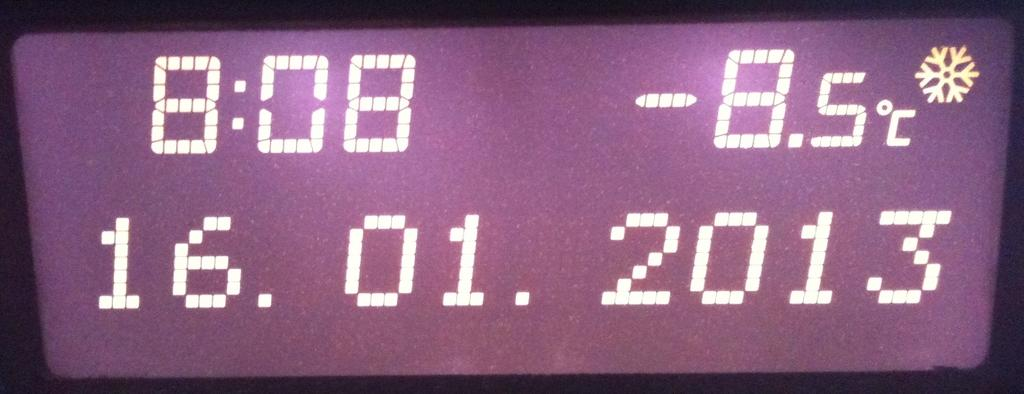<image>
Relay a brief, clear account of the picture shown. a digital display of time 8:08 on a purple background 